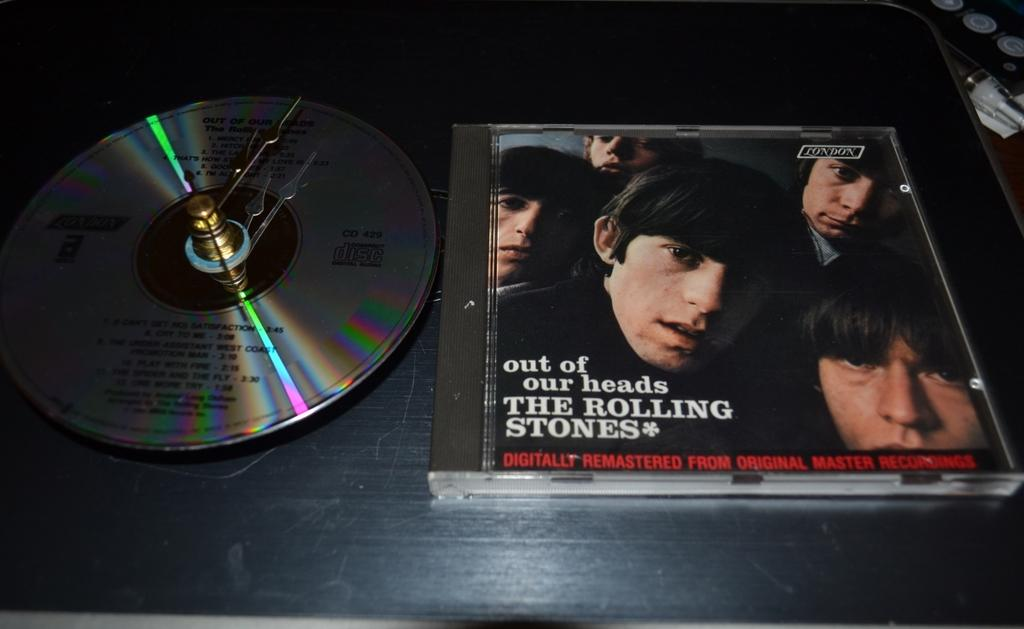What is placed on the black surface in the image? There is a DVD placed on a black surface. What else can be seen related to the DVD in the image? There is a DVD box on the right side of the image. How many fifths are visible in the image? There is no mention of a fifth or any fraction in the image, so it cannot be determined. 